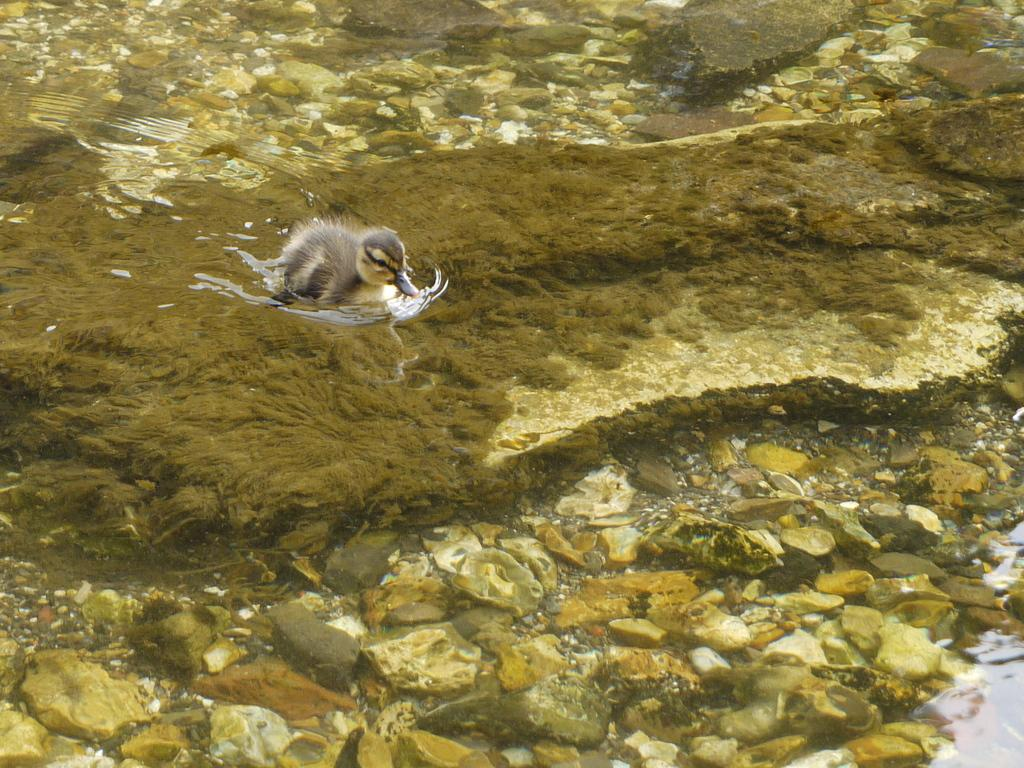What type of animal is on the moss in the image? There is a bird on the moss in the image. What is the condition of the moss? The moss is wet. What is located beside the moss? There are stones beside the moss on the left side. What can be seen on the right side of the image? There is water on the right side of the image. What can be seen in the background of the image? There are stones in the background of the image. What type of scissors can be seen cutting through the moss in the image? There are no scissors present in the image. 